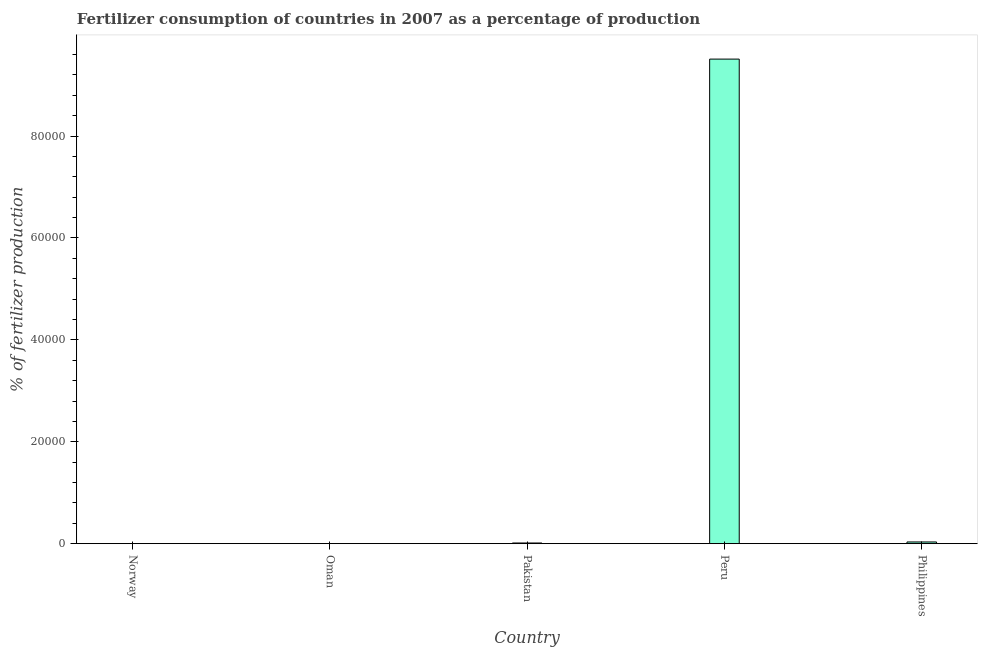Does the graph contain grids?
Offer a very short reply. No. What is the title of the graph?
Your response must be concise. Fertilizer consumption of countries in 2007 as a percentage of production. What is the label or title of the X-axis?
Offer a very short reply. Country. What is the label or title of the Y-axis?
Your response must be concise. % of fertilizer production. What is the amount of fertilizer consumption in Norway?
Provide a succinct answer. 23.42. Across all countries, what is the maximum amount of fertilizer consumption?
Ensure brevity in your answer.  9.51e+04. Across all countries, what is the minimum amount of fertilizer consumption?
Your answer should be very brief. 1.16. In which country was the amount of fertilizer consumption maximum?
Keep it short and to the point. Peru. In which country was the amount of fertilizer consumption minimum?
Keep it short and to the point. Oman. What is the sum of the amount of fertilizer consumption?
Your answer should be very brief. 9.56e+04. What is the difference between the amount of fertilizer consumption in Oman and Pakistan?
Offer a very short reply. -129.51. What is the average amount of fertilizer consumption per country?
Ensure brevity in your answer.  1.91e+04. What is the median amount of fertilizer consumption?
Provide a short and direct response. 130.68. What is the ratio of the amount of fertilizer consumption in Pakistan to that in Philippines?
Offer a terse response. 0.39. Is the amount of fertilizer consumption in Pakistan less than that in Peru?
Offer a terse response. Yes. Is the difference between the amount of fertilizer consumption in Norway and Philippines greater than the difference between any two countries?
Ensure brevity in your answer.  No. What is the difference between the highest and the second highest amount of fertilizer consumption?
Provide a short and direct response. 9.48e+04. What is the difference between the highest and the lowest amount of fertilizer consumption?
Offer a terse response. 9.51e+04. In how many countries, is the amount of fertilizer consumption greater than the average amount of fertilizer consumption taken over all countries?
Your answer should be compact. 1. How many bars are there?
Keep it short and to the point. 5. How many countries are there in the graph?
Your answer should be very brief. 5. Are the values on the major ticks of Y-axis written in scientific E-notation?
Your answer should be compact. No. What is the % of fertilizer production of Norway?
Ensure brevity in your answer.  23.42. What is the % of fertilizer production in Oman?
Give a very brief answer. 1.16. What is the % of fertilizer production in Pakistan?
Your answer should be compact. 130.68. What is the % of fertilizer production in Peru?
Provide a succinct answer. 9.51e+04. What is the % of fertilizer production of Philippines?
Give a very brief answer. 332.59. What is the difference between the % of fertilizer production in Norway and Oman?
Provide a short and direct response. 22.26. What is the difference between the % of fertilizer production in Norway and Pakistan?
Offer a terse response. -107.26. What is the difference between the % of fertilizer production in Norway and Peru?
Provide a succinct answer. -9.51e+04. What is the difference between the % of fertilizer production in Norway and Philippines?
Your answer should be very brief. -309.17. What is the difference between the % of fertilizer production in Oman and Pakistan?
Your response must be concise. -129.51. What is the difference between the % of fertilizer production in Oman and Peru?
Offer a very short reply. -9.51e+04. What is the difference between the % of fertilizer production in Oman and Philippines?
Give a very brief answer. -331.42. What is the difference between the % of fertilizer production in Pakistan and Peru?
Your answer should be compact. -9.50e+04. What is the difference between the % of fertilizer production in Pakistan and Philippines?
Your answer should be compact. -201.91. What is the difference between the % of fertilizer production in Peru and Philippines?
Offer a terse response. 9.48e+04. What is the ratio of the % of fertilizer production in Norway to that in Oman?
Your answer should be compact. 20.13. What is the ratio of the % of fertilizer production in Norway to that in Pakistan?
Your response must be concise. 0.18. What is the ratio of the % of fertilizer production in Norway to that in Philippines?
Your response must be concise. 0.07. What is the ratio of the % of fertilizer production in Oman to that in Pakistan?
Provide a succinct answer. 0.01. What is the ratio of the % of fertilizer production in Oman to that in Philippines?
Ensure brevity in your answer.  0. What is the ratio of the % of fertilizer production in Pakistan to that in Peru?
Provide a short and direct response. 0. What is the ratio of the % of fertilizer production in Pakistan to that in Philippines?
Your response must be concise. 0.39. What is the ratio of the % of fertilizer production in Peru to that in Philippines?
Your answer should be very brief. 285.96. 